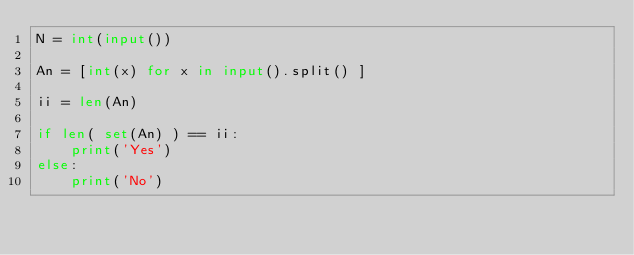<code> <loc_0><loc_0><loc_500><loc_500><_Python_>N = int(input()) 

An = [int(x) for x in input().split() ]

ii = len(An)

if len( set(An) ) == ii:
    print('Yes')
else:
    print('No')
</code> 